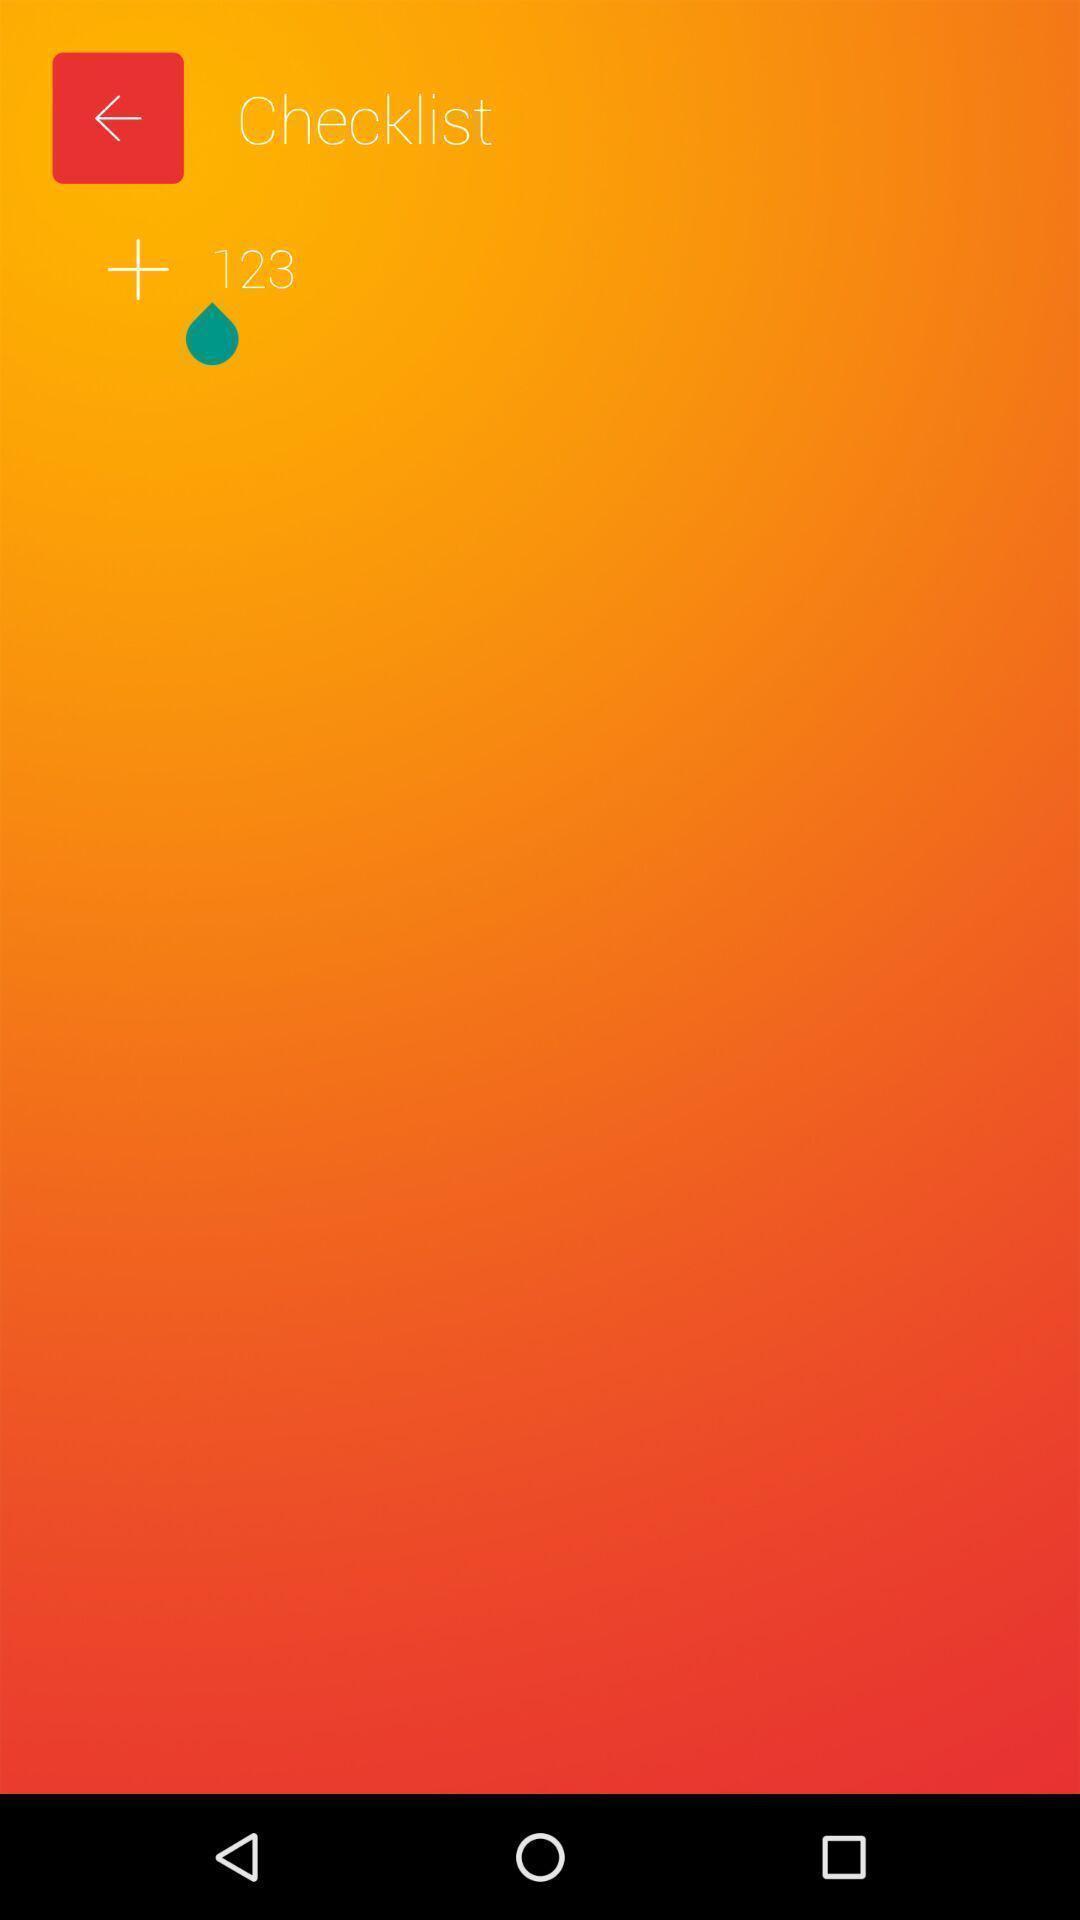Summarize the main components in this picture. Page showing add option in checklist. 